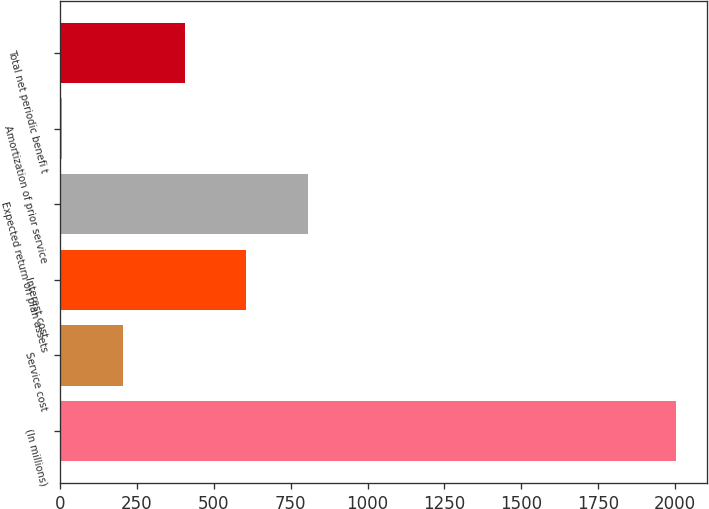Convert chart to OTSL. <chart><loc_0><loc_0><loc_500><loc_500><bar_chart><fcel>(In millions)<fcel>Service cost<fcel>Interest cost<fcel>Expected return on plan assets<fcel>Amortization of prior service<fcel>Total net periodic benefi t<nl><fcel>2005<fcel>204.73<fcel>604.79<fcel>804.82<fcel>4.7<fcel>404.76<nl></chart> 